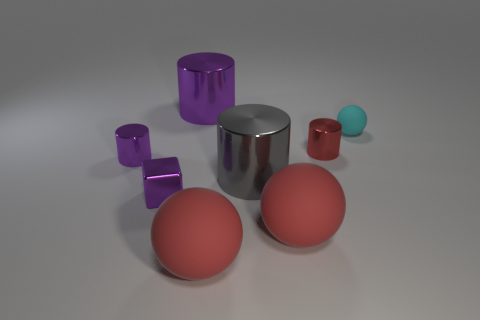Subtract all red cylinders. How many red balls are left? 2 Subtract all big red balls. How many balls are left? 1 Subtract 1 balls. How many balls are left? 2 Subtract all red cylinders. How many cylinders are left? 3 Add 1 red cylinders. How many objects exist? 9 Subtract all blocks. How many objects are left? 7 Subtract all yellow cylinders. Subtract all yellow spheres. How many cylinders are left? 4 Add 2 small blocks. How many small blocks exist? 3 Subtract 1 red cylinders. How many objects are left? 7 Subtract all big cyan metal objects. Subtract all cyan balls. How many objects are left? 7 